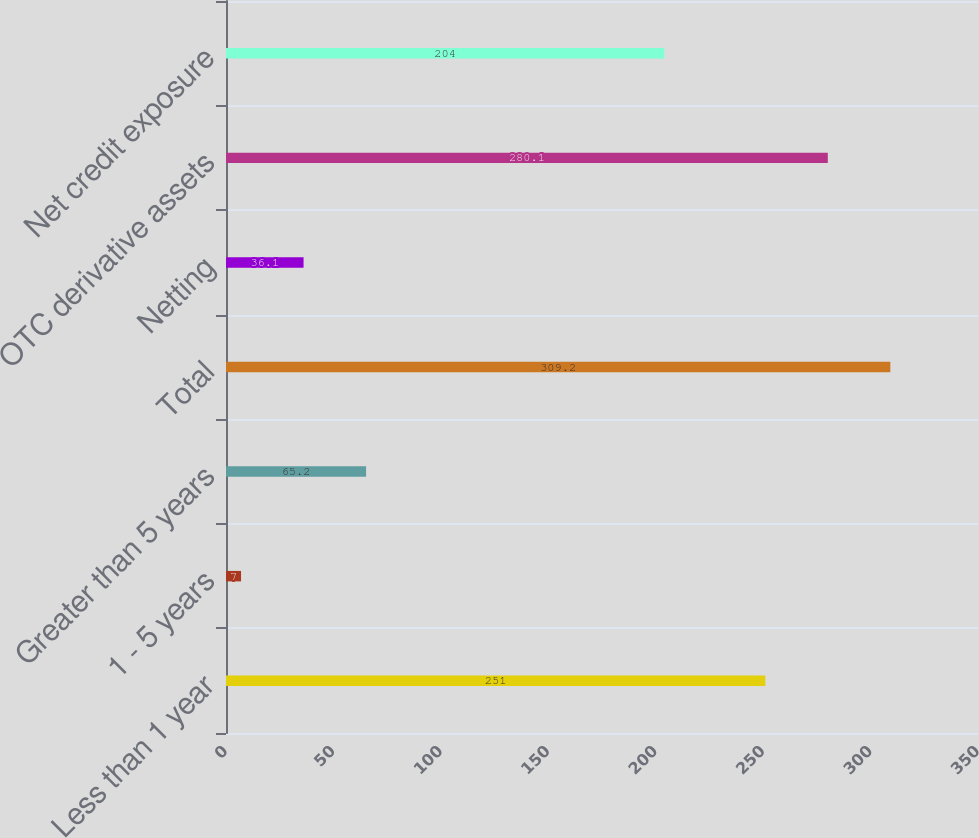<chart> <loc_0><loc_0><loc_500><loc_500><bar_chart><fcel>Less than 1 year<fcel>1 - 5 years<fcel>Greater than 5 years<fcel>Total<fcel>Netting<fcel>OTC derivative assets<fcel>Net credit exposure<nl><fcel>251<fcel>7<fcel>65.2<fcel>309.2<fcel>36.1<fcel>280.1<fcel>204<nl></chart> 